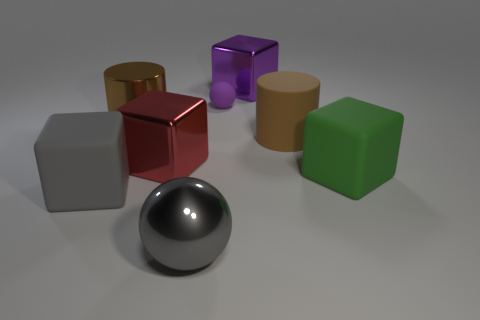What is the material of the other brown object that is the same size as the brown matte thing?
Make the answer very short. Metal. What size is the thing that is to the left of the brown cylinder that is to the left of the gray shiny thing?
Provide a short and direct response. Large. There is a ball in front of the red shiny block; is its size the same as the brown rubber object?
Keep it short and to the point. Yes. Is the number of metallic cylinders that are right of the big sphere greater than the number of big cylinders behind the big brown metal cylinder?
Keep it short and to the point. No. There is a large thing that is both behind the large red block and to the right of the purple shiny block; what is its shape?
Ensure brevity in your answer.  Cylinder. What is the shape of the gray rubber object that is in front of the tiny purple object?
Make the answer very short. Cube. How big is the ball that is behind the matte cube that is left of the metallic block right of the small purple matte ball?
Keep it short and to the point. Small. Is the shape of the small matte thing the same as the big green object?
Keep it short and to the point. No. There is a cube that is in front of the tiny purple object and to the right of the large shiny ball; how big is it?
Provide a short and direct response. Large. There is another object that is the same shape as the small purple object; what material is it?
Offer a terse response. Metal. 